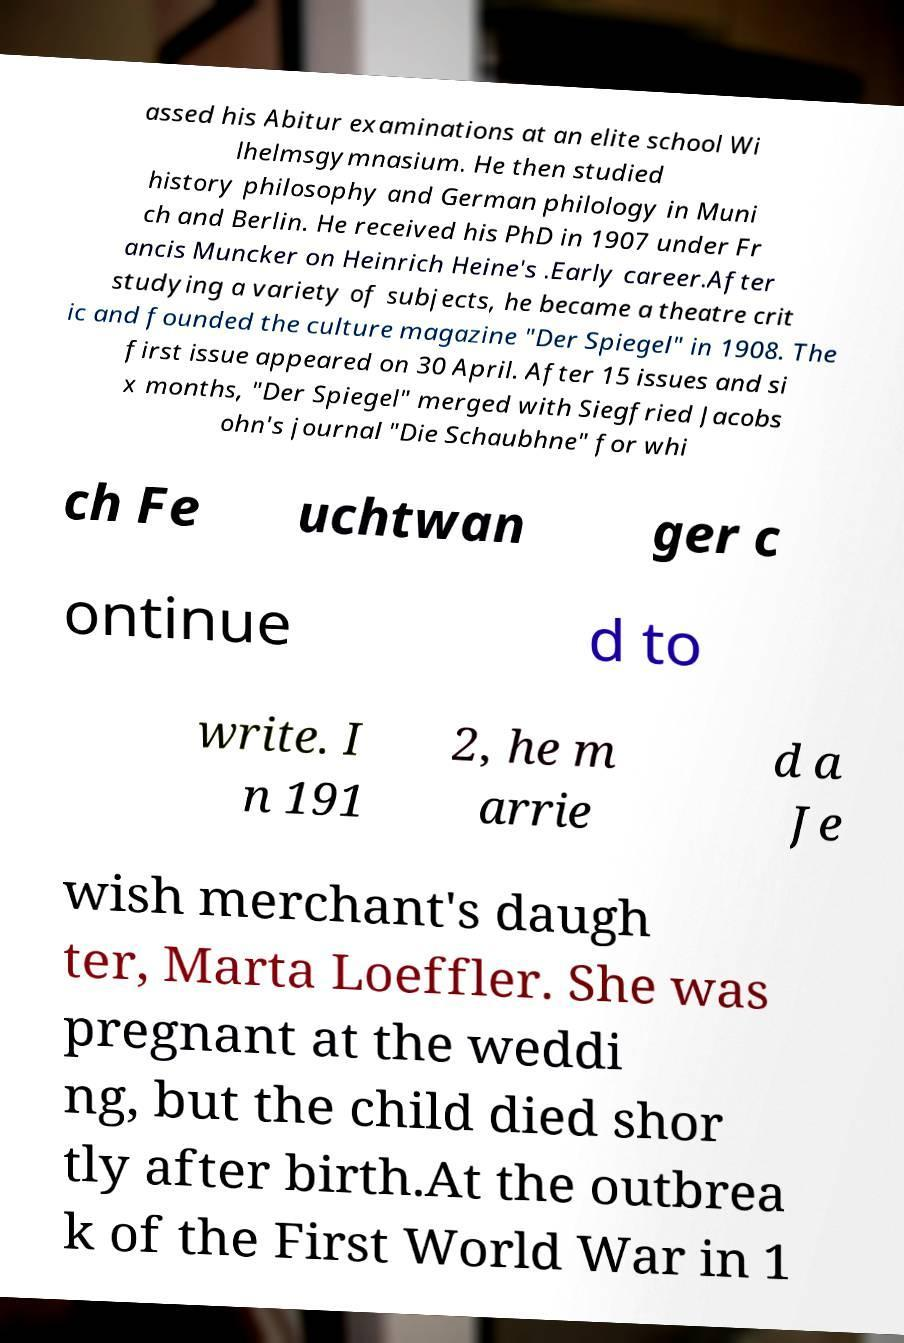Please read and relay the text visible in this image. What does it say? assed his Abitur examinations at an elite school Wi lhelmsgymnasium. He then studied history philosophy and German philology in Muni ch and Berlin. He received his PhD in 1907 under Fr ancis Muncker on Heinrich Heine's .Early career.After studying a variety of subjects, he became a theatre crit ic and founded the culture magazine "Der Spiegel" in 1908. The first issue appeared on 30 April. After 15 issues and si x months, "Der Spiegel" merged with Siegfried Jacobs ohn's journal "Die Schaubhne" for whi ch Fe uchtwan ger c ontinue d to write. I n 191 2, he m arrie d a Je wish merchant's daugh ter, Marta Loeffler. She was pregnant at the weddi ng, but the child died shor tly after birth.At the outbrea k of the First World War in 1 